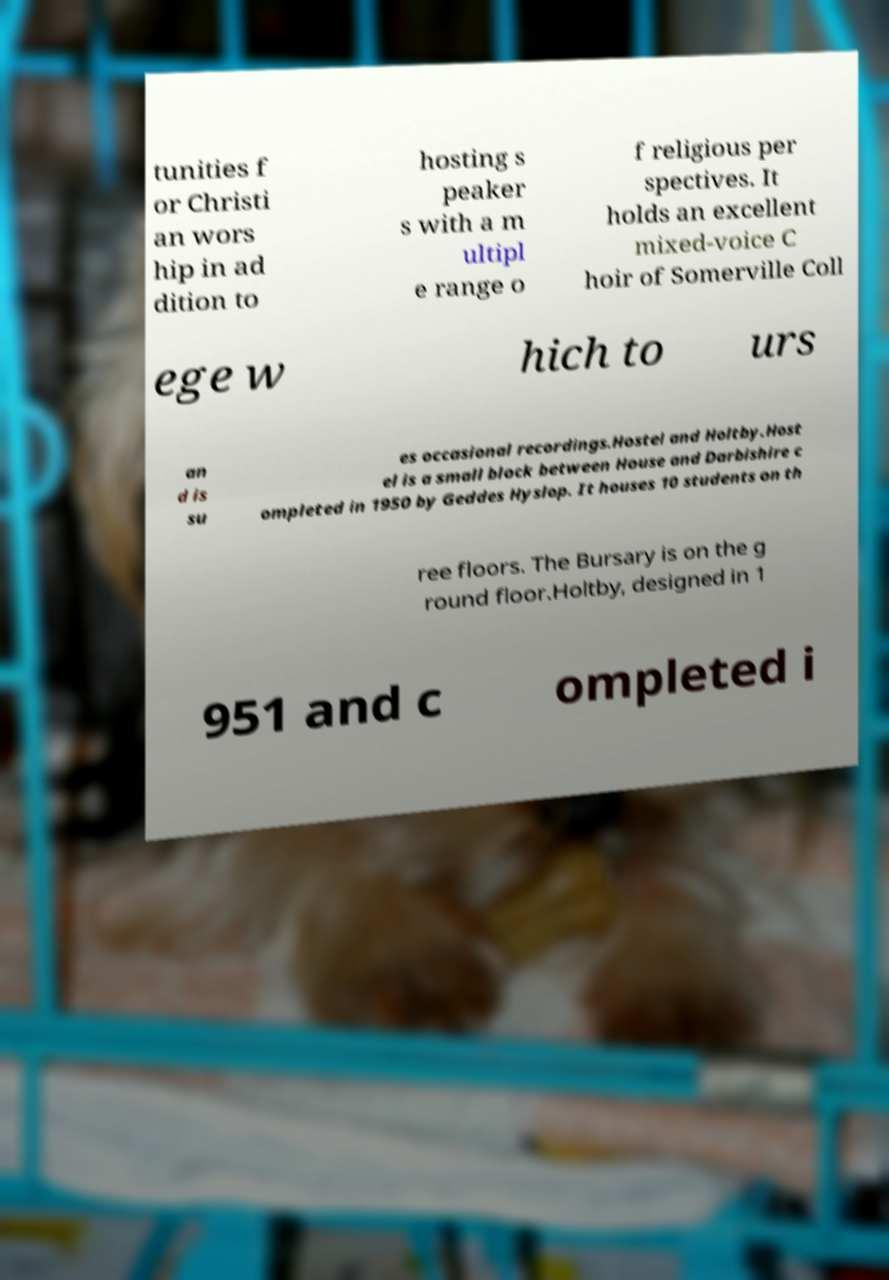Could you assist in decoding the text presented in this image and type it out clearly? tunities f or Christi an wors hip in ad dition to hosting s peaker s with a m ultipl e range o f religious per spectives. It holds an excellent mixed-voice C hoir of Somerville Coll ege w hich to urs an d is su es occasional recordings.Hostel and Holtby.Host el is a small block between House and Darbishire c ompleted in 1950 by Geddes Hyslop. It houses 10 students on th ree floors. The Bursary is on the g round floor.Holtby, designed in 1 951 and c ompleted i 